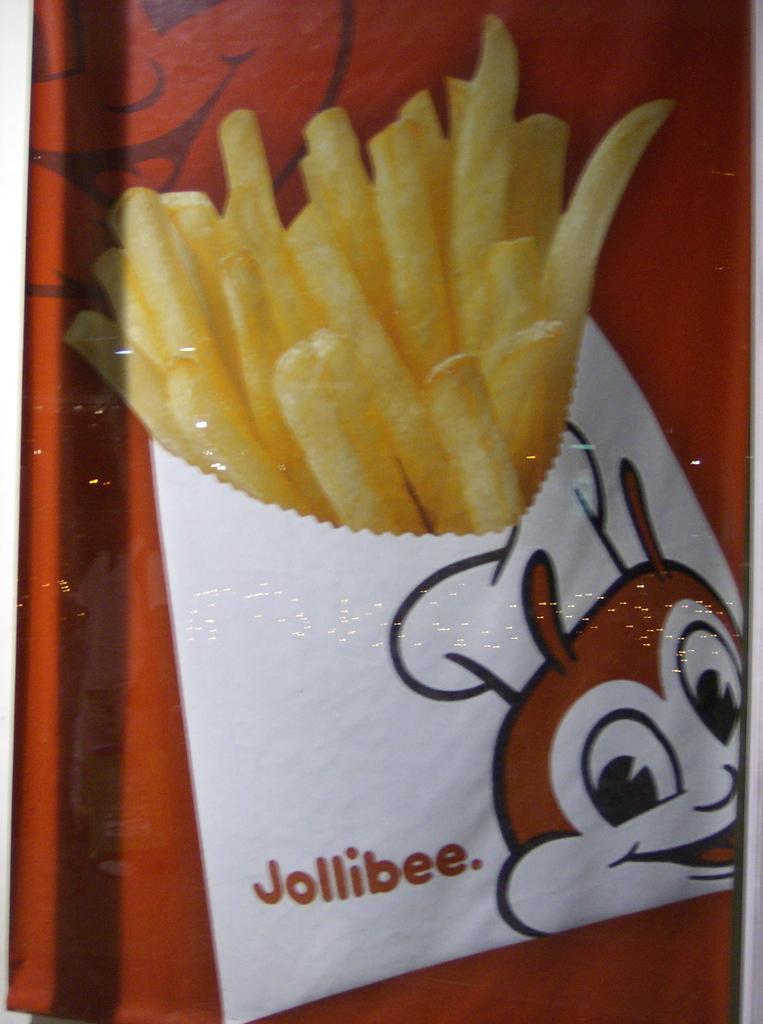How would you summarize this image in a sentence or two? Here we can see a picture of french fries and cartoon image. Background it is in red color. 